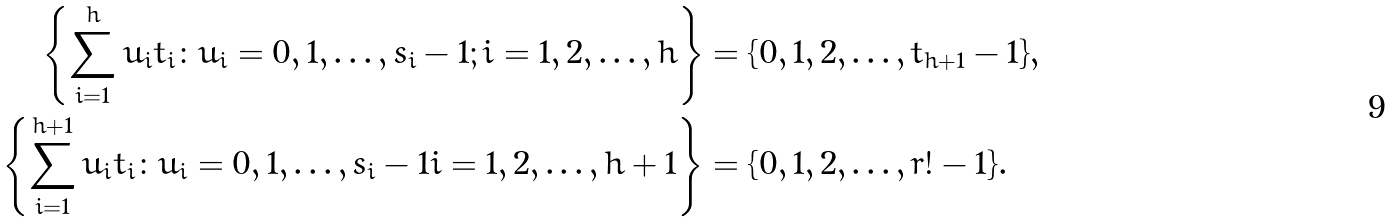<formula> <loc_0><loc_0><loc_500><loc_500>\left \{ \sum _ { i = 1 } ^ { h } u _ { i } t _ { i } \colon u _ { i } = 0 , 1 , \dots , s _ { i } - 1 ; i = 1 , 2 , \dots , h \right \} & = \{ 0 , 1 , 2 , \dots , t _ { h + 1 } - 1 \} , \\ \left \{ \sum _ { i = 1 } ^ { h + 1 } u _ { i } t _ { i } \colon u _ { i } = 0 , 1 , \dots , s _ { i } - 1 i = 1 , 2 , \dots , h + 1 \right \} & = \{ 0 , 1 , 2 , \dots , r ! - 1 \} .</formula> 